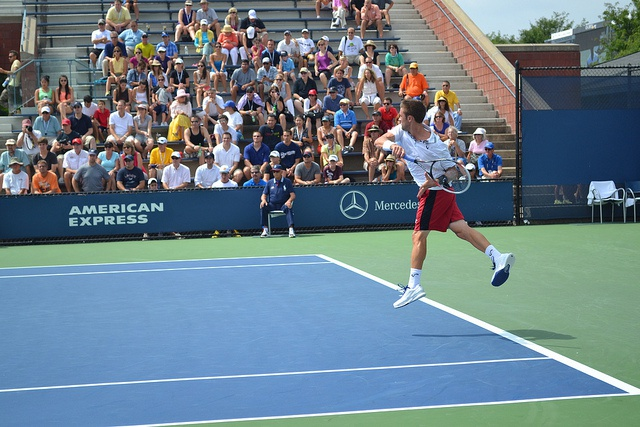Describe the objects in this image and their specific colors. I can see people in darkgray, gray, and black tones, people in darkgray, gray, maroon, and black tones, tennis racket in darkgray, gray, and blue tones, chair in darkgray, lightblue, black, and gray tones, and people in darkgray, black, gray, and tan tones in this image. 